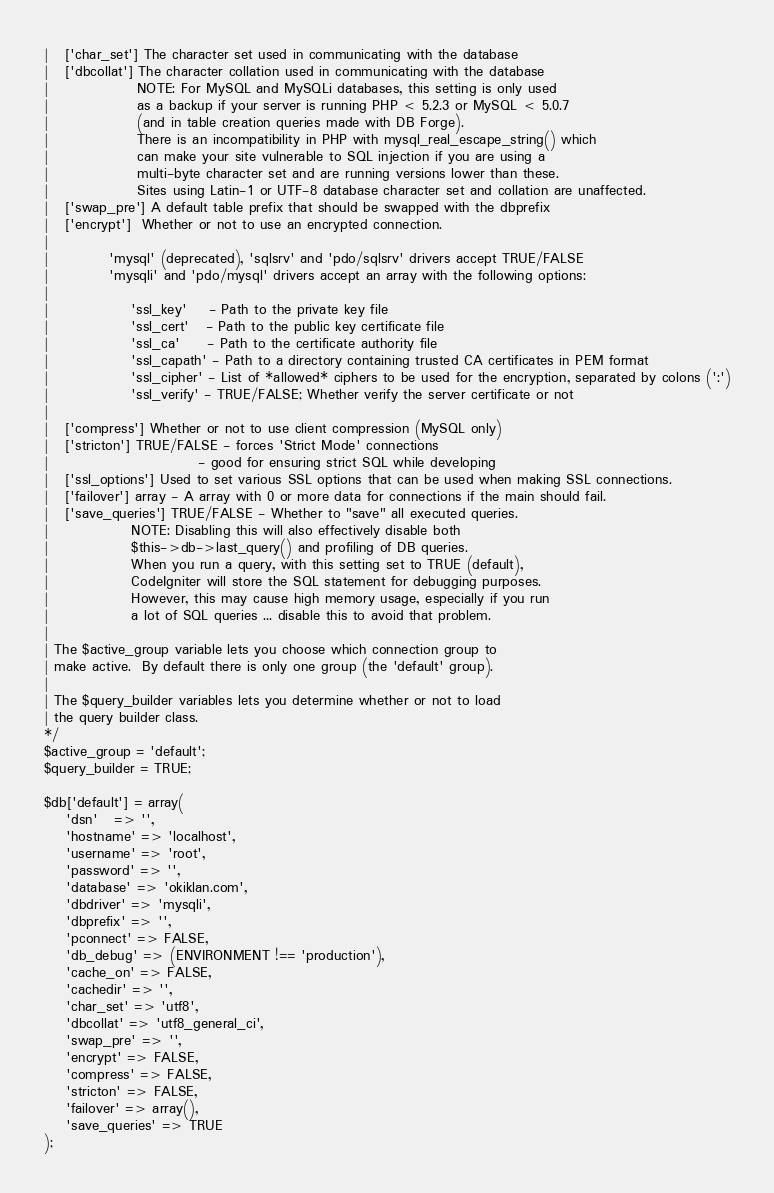<code> <loc_0><loc_0><loc_500><loc_500><_PHP_>|	['char_set'] The character set used in communicating with the database
|	['dbcollat'] The character collation used in communicating with the database
|				 NOTE: For MySQL and MySQLi databases, this setting is only used
| 				 as a backup if your server is running PHP < 5.2.3 or MySQL < 5.0.7
|				 (and in table creation queries made with DB Forge).
| 				 There is an incompatibility in PHP with mysql_real_escape_string() which
| 				 can make your site vulnerable to SQL injection if you are using a
| 				 multi-byte character set and are running versions lower than these.
| 				 Sites using Latin-1 or UTF-8 database character set and collation are unaffected.
|	['swap_pre'] A default table prefix that should be swapped with the dbprefix
|	['encrypt']  Whether or not to use an encrypted connection.
|
|			'mysql' (deprecated), 'sqlsrv' and 'pdo/sqlsrv' drivers accept TRUE/FALSE
|			'mysqli' and 'pdo/mysql' drivers accept an array with the following options:
|
|				'ssl_key'    - Path to the private key file
|				'ssl_cert'   - Path to the public key certificate file
|				'ssl_ca'     - Path to the certificate authority file
|				'ssl_capath' - Path to a directory containing trusted CA certificates in PEM format
|				'ssl_cipher' - List of *allowed* ciphers to be used for the encryption, separated by colons (':')
|				'ssl_verify' - TRUE/FALSE; Whether verify the server certificate or not
|
|	['compress'] Whether or not to use client compression (MySQL only)
|	['stricton'] TRUE/FALSE - forces 'Strict Mode' connections
|							- good for ensuring strict SQL while developing
|	['ssl_options']	Used to set various SSL options that can be used when making SSL connections.
|	['failover'] array - A array with 0 or more data for connections if the main should fail.
|	['save_queries'] TRUE/FALSE - Whether to "save" all executed queries.
| 				NOTE: Disabling this will also effectively disable both
| 				$this->db->last_query() and profiling of DB queries.
| 				When you run a query, with this setting set to TRUE (default),
| 				CodeIgniter will store the SQL statement for debugging purposes.
| 				However, this may cause high memory usage, especially if you run
| 				a lot of SQL queries ... disable this to avoid that problem.
|
| The $active_group variable lets you choose which connection group to
| make active.  By default there is only one group (the 'default' group).
|
| The $query_builder variables lets you determine whether or not to load
| the query builder class.
*/
$active_group = 'default';
$query_builder = TRUE;

$db['default'] = array(
	'dsn'	=> '',
	'hostname' => 'localhost',
	'username' => 'root',
	'password' => '',
	'database' => 'okiklan.com',
	'dbdriver' => 'mysqli',
	'dbprefix' => '',
	'pconnect' => FALSE,
	'db_debug' => (ENVIRONMENT !== 'production'),
	'cache_on' => FALSE,
	'cachedir' => '',
	'char_set' => 'utf8',
	'dbcollat' => 'utf8_general_ci',
	'swap_pre' => '',
	'encrypt' => FALSE,
	'compress' => FALSE,
	'stricton' => FALSE,
	'failover' => array(),
	'save_queries' => TRUE
);
</code> 